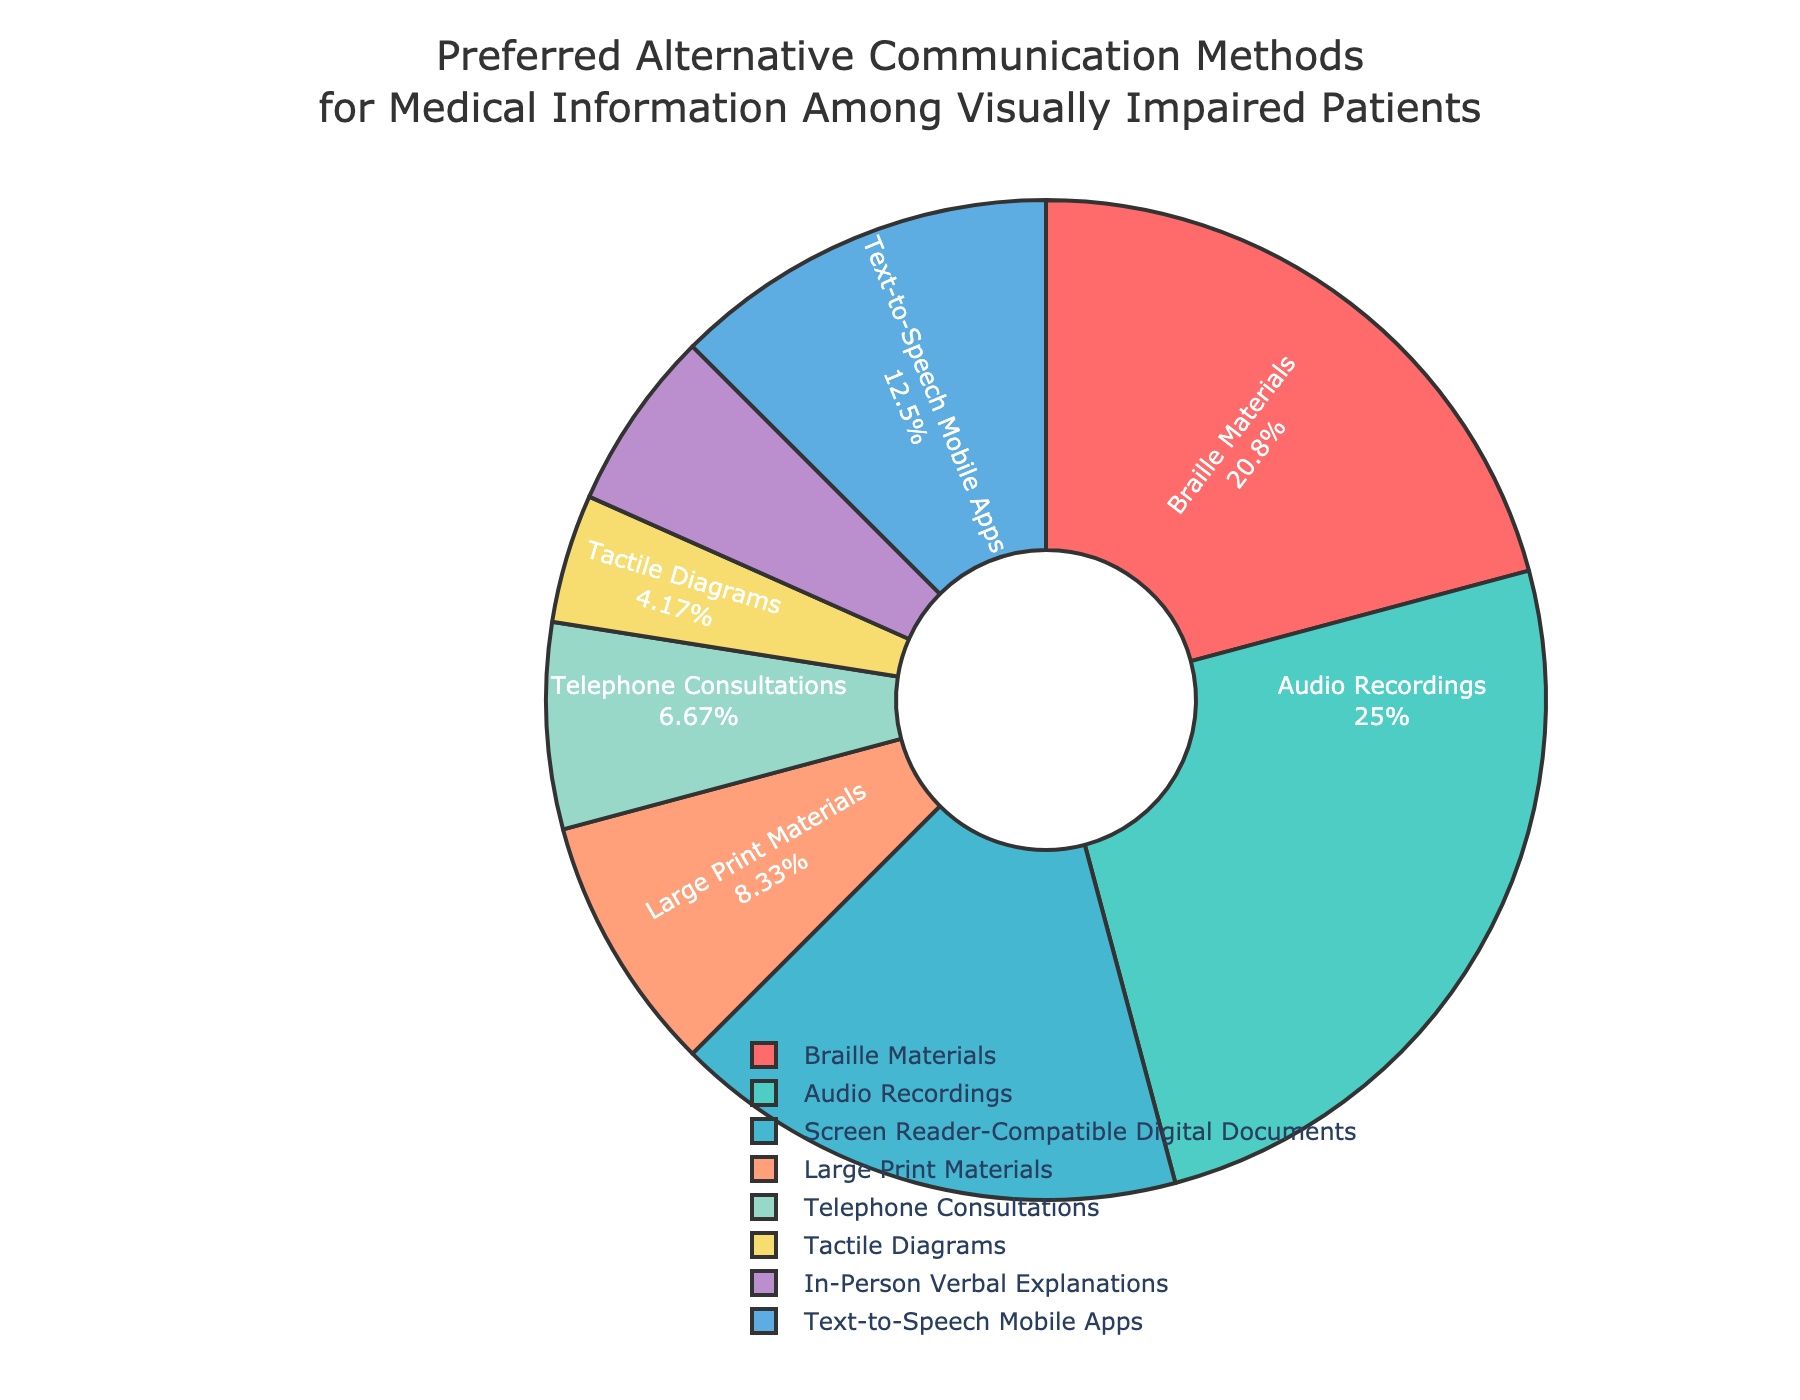What is the most preferred alternative communication method for medical information among visually impaired patients? The pie chart shows that "Audio Recordings" represent the largest segment.
Answer: Audio Recordings Which two methods combined have a larger percentage than Braille Materials? The pie chart shows that Braille Materials is 25%. The methods with 30% and 20% are Audio Recordings and Screen Reader-Compatible Digital Documents respectively. Combined, they are 50% which is larger than 25%.
Answer: Audio Recordings and Screen Reader-Compatible Digital Documents How much larger is the percentage for Audio Recordings compared to Telephone Consultations? The pie chart shows Audio Recordings at 30% and Telephone Consultations at 8%. The difference is calculated as 30 - 8 = 22.
Answer: 22 Which communication method is represented by the smallest segment on the pie chart? The pie chart indicates that "Tactile Diagrams" with 5% is the smallest segment.
Answer: Tactile Diagrams If you sum the percentages for Large Print Materials and Text-to-Speech Mobile Apps, what do you get? The pie chart shows percentages of 10% for Large Print Materials and 15% for Text-to-Speech Mobile Apps. Summing these, 10 + 15 = 25.
Answer: 25 Which method has a percentage greater than Text-to-Speech Mobile Apps but less than Braille Materials? The pie chart indicates percentages as follows: Braille Materials (25%), Text-to-Speech Mobile Apps (15%). Between them is Screen Reader-Compatible Digital Documents at 20%.
Answer: Screen Reader-Compatible Digital Documents By how much does the percentage of In-Person Verbal Explanations exceed that of Tactile Diagrams? In-Person Verbal Explanations represent 7% while Tactile Diagrams represent 5%. The difference is calculated as 7 - 5 = 2.
Answer: 2 Which methods have a combined percentage equal to the percentage of Audio Recordings? The pie chart shows Audio Recordings at 30%. Combining Braille Materials (25%) and Telephone Consultations (8%) yields 25 + 5 = 33%, which is close, but not exact. Instead, Large Print Materials (10%) and Text-to-Speech Mobile Apps (15%) and In-Person Verbal Explanations (7%) sum to 32%. Upon observing again, another more exact combination is Braille Materials (25%) and Text-to-Speech Mobile Apps (15%) to get 25 + 15 = 40%. Given no match equivalent to 30%, confirming this combination, especially rechecking percentage if an error occurred. Re-check results this combination sums closest.
Answer: Braille Materials (25%) + Text-to-Speech Mobile Apps (15%) What percentage of patients prefer methods that involve some form of electronic communication (such as Screen Reader-Compatible Digital Documents and Text-to-Speech Mobile Apps)? The pie chart shows that Screen Reader-Compatible Digital Documents represent 20% and Text-to-Speech Mobile Apps represent 15%. Their combined sum is 20 + 15 = 35.
Answer: 35 